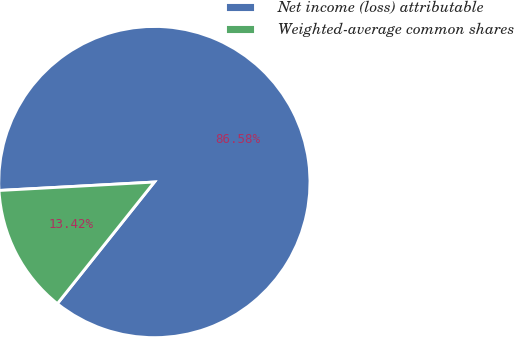Convert chart to OTSL. <chart><loc_0><loc_0><loc_500><loc_500><pie_chart><fcel>Net income (loss) attributable<fcel>Weighted-average common shares<nl><fcel>86.58%<fcel>13.42%<nl></chart> 